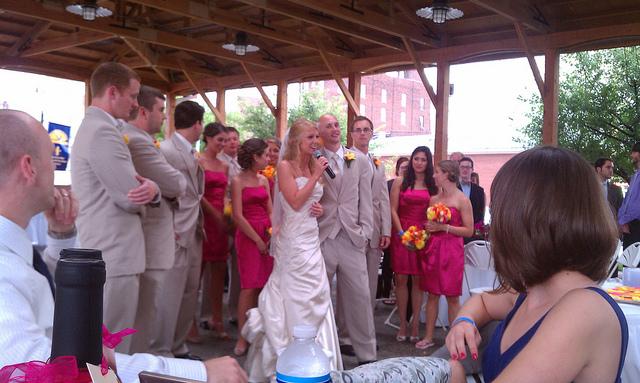Is this a wedding?
Write a very short answer. Yes. What color are the flowers?
Quick response, please. Yellow and orange. Who are the women in the pink dresses?
Short answer required. Bridesmaids. 